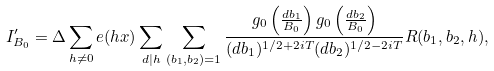Convert formula to latex. <formula><loc_0><loc_0><loc_500><loc_500>I _ { B _ { 0 } } ^ { \prime } = \Delta \sum _ { h \neq 0 } e ( h x ) \sum _ { d | h } \sum _ { ( b _ { 1 } , b _ { 2 } ) = 1 } \frac { g _ { 0 } \left ( \frac { d b _ { 1 } } { B _ { 0 } } \right ) g _ { 0 } \left ( \frac { d b _ { 2 } } { B _ { 0 } } \right ) } { ( d b _ { 1 } ) ^ { 1 / 2 + 2 i T } ( d b _ { 2 } ) ^ { 1 / 2 - 2 i T } } R ( b _ { 1 } , b _ { 2 } , h ) ,</formula> 